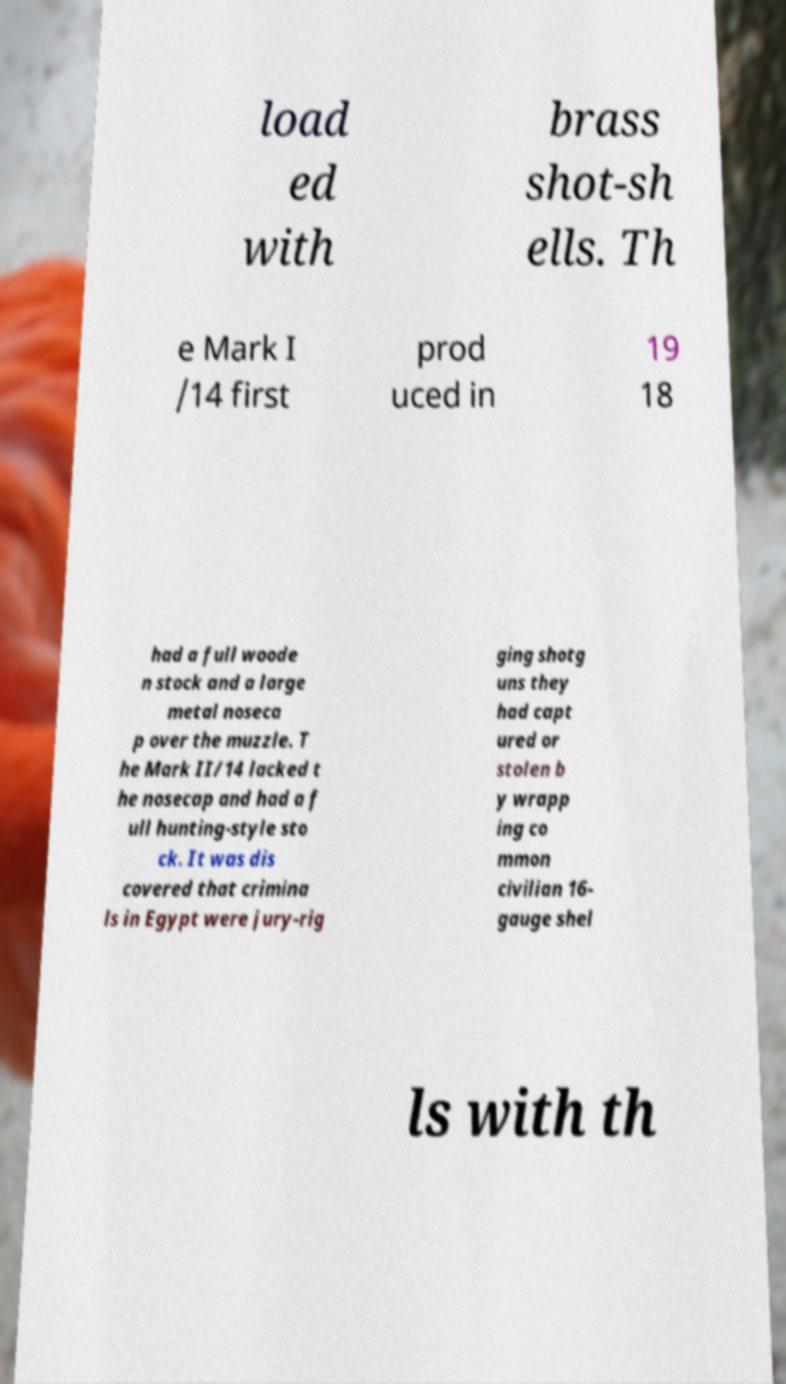Could you assist in decoding the text presented in this image and type it out clearly? load ed with brass shot-sh ells. Th e Mark I /14 first prod uced in 19 18 had a full woode n stock and a large metal noseca p over the muzzle. T he Mark II/14 lacked t he nosecap and had a f ull hunting-style sto ck. It was dis covered that crimina ls in Egypt were jury-rig ging shotg uns they had capt ured or stolen b y wrapp ing co mmon civilian 16- gauge shel ls with th 